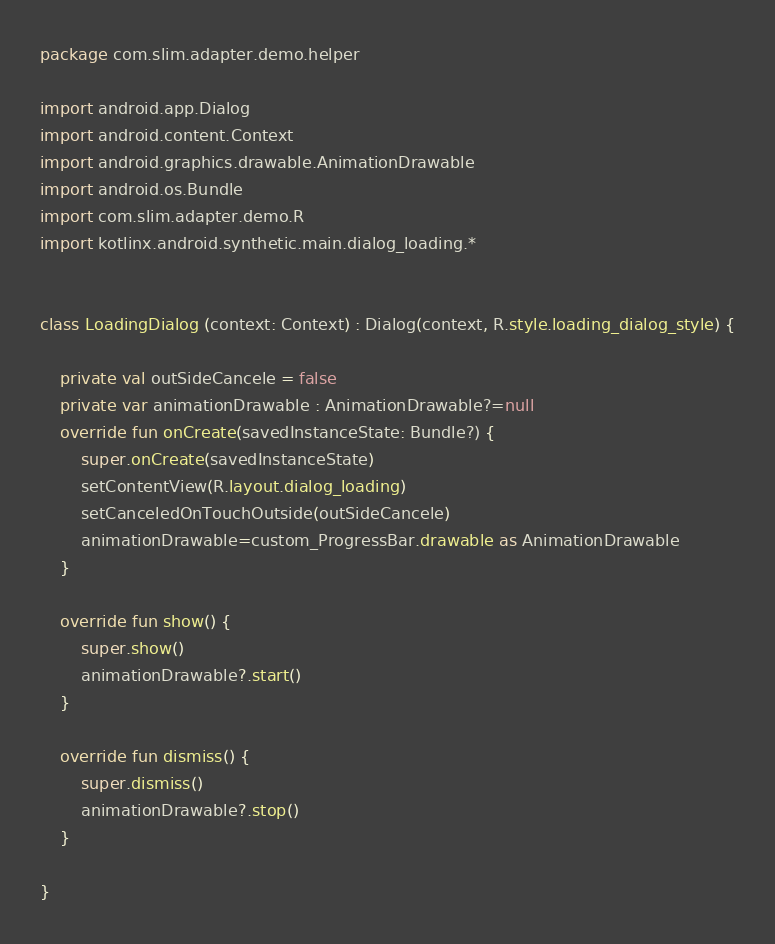<code> <loc_0><loc_0><loc_500><loc_500><_Kotlin_>package com.slim.adapter.demo.helper

import android.app.Dialog
import android.content.Context
import android.graphics.drawable.AnimationDrawable
import android.os.Bundle
import com.slim.adapter.demo.R
import kotlinx.android.synthetic.main.dialog_loading.*


class LoadingDialog (context: Context) : Dialog(context, R.style.loading_dialog_style) {

    private val outSideCancele = false
    private var animationDrawable : AnimationDrawable?=null
    override fun onCreate(savedInstanceState: Bundle?) {
        super.onCreate(savedInstanceState)
        setContentView(R.layout.dialog_loading)
        setCanceledOnTouchOutside(outSideCancele)
        animationDrawable=custom_ProgressBar.drawable as AnimationDrawable
    }

    override fun show() {
        super.show()
        animationDrawable?.start()
    }

    override fun dismiss() {
        super.dismiss()
        animationDrawable?.stop()
    }

}
</code> 